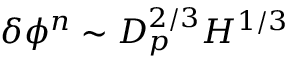<formula> <loc_0><loc_0><loc_500><loc_500>\delta \phi ^ { n } \sim D _ { p } ^ { 2 / 3 } H ^ { 1 / 3 }</formula> 